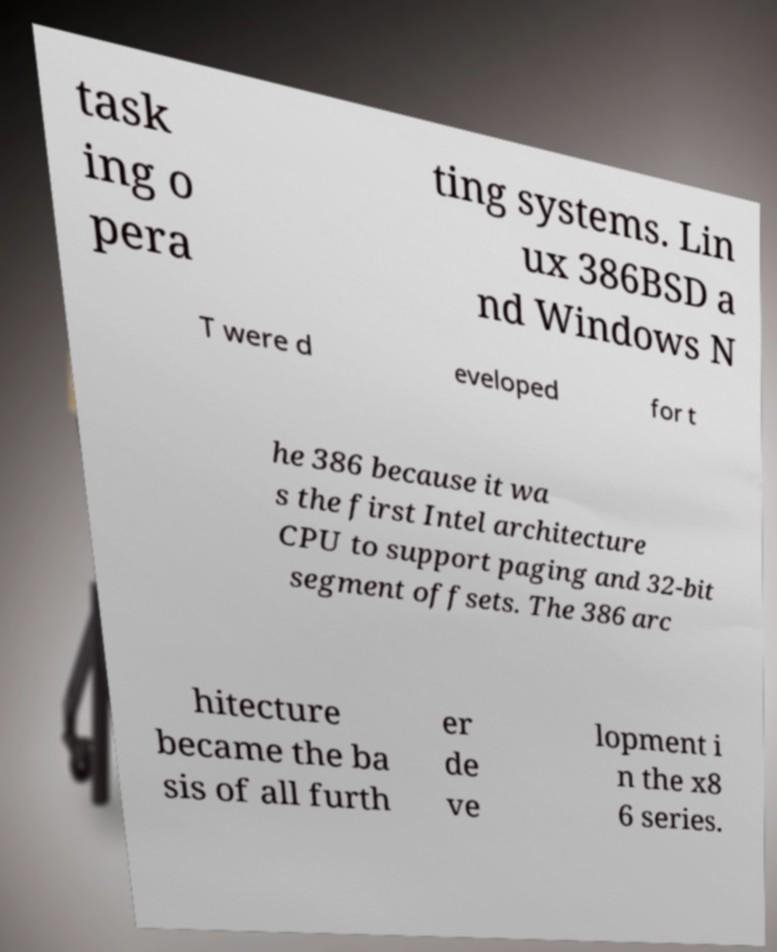For documentation purposes, I need the text within this image transcribed. Could you provide that? task ing o pera ting systems. Lin ux 386BSD a nd Windows N T were d eveloped for t he 386 because it wa s the first Intel architecture CPU to support paging and 32-bit segment offsets. The 386 arc hitecture became the ba sis of all furth er de ve lopment i n the x8 6 series. 